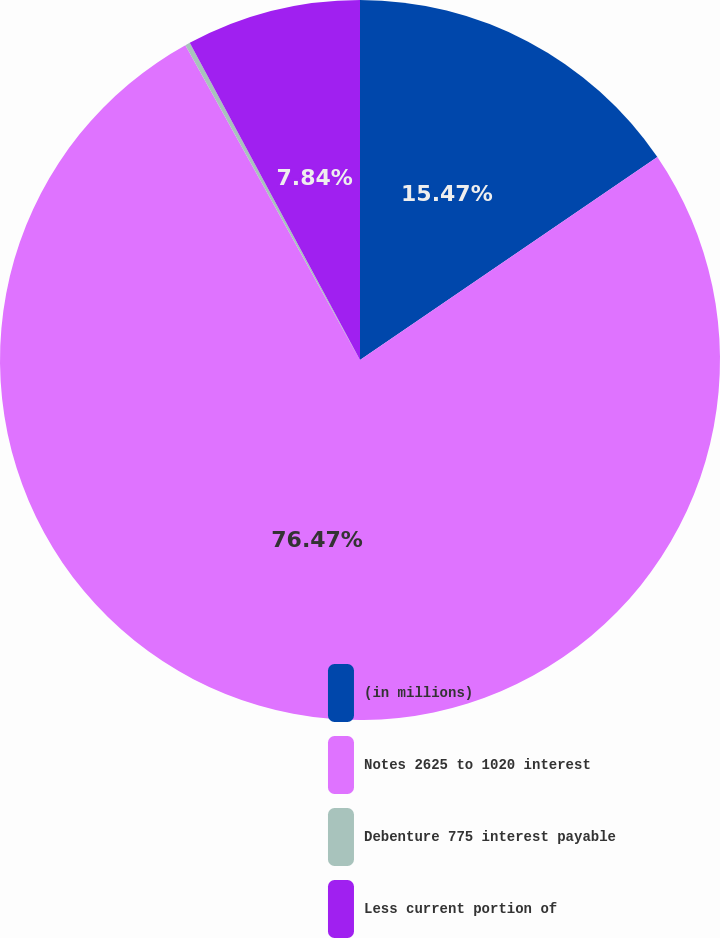Convert chart to OTSL. <chart><loc_0><loc_0><loc_500><loc_500><pie_chart><fcel>(in millions)<fcel>Notes 2625 to 1020 interest<fcel>Debenture 775 interest payable<fcel>Less current portion of<nl><fcel>15.47%<fcel>76.47%<fcel>0.22%<fcel>7.84%<nl></chart> 